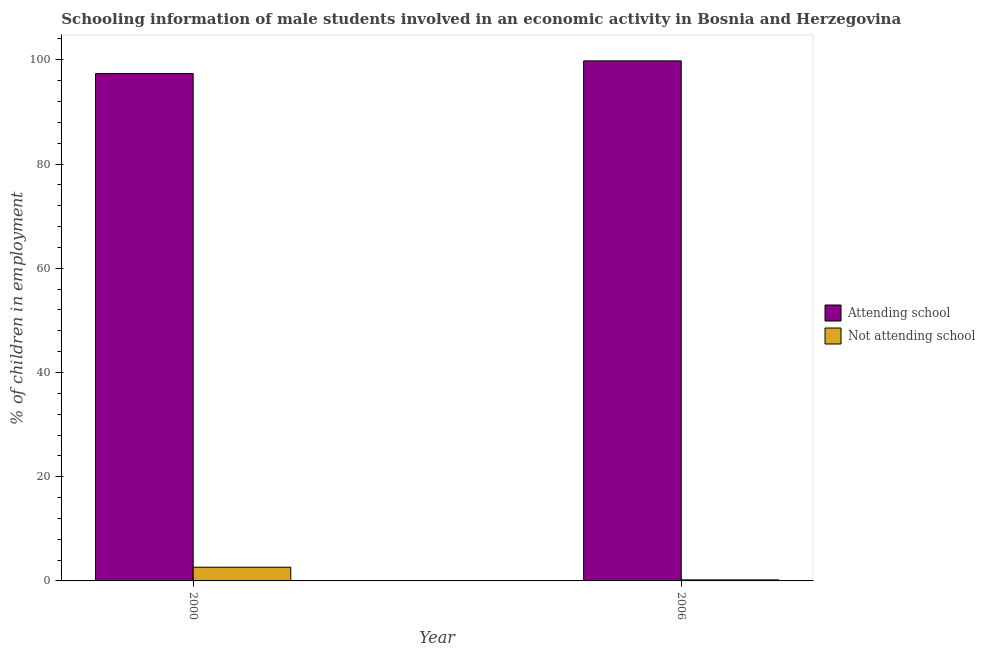How many different coloured bars are there?
Make the answer very short. 2. How many groups of bars are there?
Provide a succinct answer. 2. Are the number of bars per tick equal to the number of legend labels?
Give a very brief answer. Yes. Are the number of bars on each tick of the X-axis equal?
Your answer should be compact. Yes. How many bars are there on the 2nd tick from the left?
Your answer should be very brief. 2. How many bars are there on the 1st tick from the right?
Offer a very short reply. 2. What is the percentage of employed males who are attending school in 2006?
Your response must be concise. 99.8. Across all years, what is the maximum percentage of employed males who are attending school?
Provide a succinct answer. 99.8. Across all years, what is the minimum percentage of employed males who are attending school?
Offer a very short reply. 97.37. What is the total percentage of employed males who are attending school in the graph?
Provide a short and direct response. 197.17. What is the difference between the percentage of employed males who are attending school in 2000 and that in 2006?
Provide a short and direct response. -2.43. What is the difference between the percentage of employed males who are attending school in 2006 and the percentage of employed males who are not attending school in 2000?
Offer a very short reply. 2.43. What is the average percentage of employed males who are attending school per year?
Your answer should be compact. 98.58. In how many years, is the percentage of employed males who are attending school greater than 76 %?
Provide a short and direct response. 2. What is the ratio of the percentage of employed males who are attending school in 2000 to that in 2006?
Give a very brief answer. 0.98. What does the 2nd bar from the left in 2000 represents?
Offer a terse response. Not attending school. What does the 1st bar from the right in 2006 represents?
Keep it short and to the point. Not attending school. How many years are there in the graph?
Make the answer very short. 2. Are the values on the major ticks of Y-axis written in scientific E-notation?
Give a very brief answer. No. Does the graph contain any zero values?
Keep it short and to the point. No. Does the graph contain grids?
Make the answer very short. No. How are the legend labels stacked?
Give a very brief answer. Vertical. What is the title of the graph?
Your response must be concise. Schooling information of male students involved in an economic activity in Bosnia and Herzegovina. Does "Canada" appear as one of the legend labels in the graph?
Provide a succinct answer. No. What is the label or title of the X-axis?
Your response must be concise. Year. What is the label or title of the Y-axis?
Ensure brevity in your answer.  % of children in employment. What is the % of children in employment in Attending school in 2000?
Give a very brief answer. 97.37. What is the % of children in employment in Not attending school in 2000?
Your answer should be compact. 2.63. What is the % of children in employment of Attending school in 2006?
Offer a very short reply. 99.8. What is the % of children in employment in Not attending school in 2006?
Keep it short and to the point. 0.2. Across all years, what is the maximum % of children in employment of Attending school?
Provide a succinct answer. 99.8. Across all years, what is the maximum % of children in employment of Not attending school?
Your response must be concise. 2.63. Across all years, what is the minimum % of children in employment in Attending school?
Ensure brevity in your answer.  97.37. Across all years, what is the minimum % of children in employment of Not attending school?
Your response must be concise. 0.2. What is the total % of children in employment in Attending school in the graph?
Your answer should be compact. 197.17. What is the total % of children in employment of Not attending school in the graph?
Your answer should be very brief. 2.83. What is the difference between the % of children in employment of Attending school in 2000 and that in 2006?
Give a very brief answer. -2.43. What is the difference between the % of children in employment of Not attending school in 2000 and that in 2006?
Your answer should be compact. 2.43. What is the difference between the % of children in employment in Attending school in 2000 and the % of children in employment in Not attending school in 2006?
Give a very brief answer. 97.17. What is the average % of children in employment of Attending school per year?
Provide a succinct answer. 98.58. What is the average % of children in employment in Not attending school per year?
Ensure brevity in your answer.  1.42. In the year 2000, what is the difference between the % of children in employment in Attending school and % of children in employment in Not attending school?
Make the answer very short. 94.74. In the year 2006, what is the difference between the % of children in employment in Attending school and % of children in employment in Not attending school?
Keep it short and to the point. 99.6. What is the ratio of the % of children in employment in Attending school in 2000 to that in 2006?
Give a very brief answer. 0.98. What is the ratio of the % of children in employment in Not attending school in 2000 to that in 2006?
Give a very brief answer. 13.16. What is the difference between the highest and the second highest % of children in employment in Attending school?
Your response must be concise. 2.43. What is the difference between the highest and the second highest % of children in employment in Not attending school?
Your answer should be compact. 2.43. What is the difference between the highest and the lowest % of children in employment of Attending school?
Your answer should be very brief. 2.43. What is the difference between the highest and the lowest % of children in employment of Not attending school?
Your response must be concise. 2.43. 